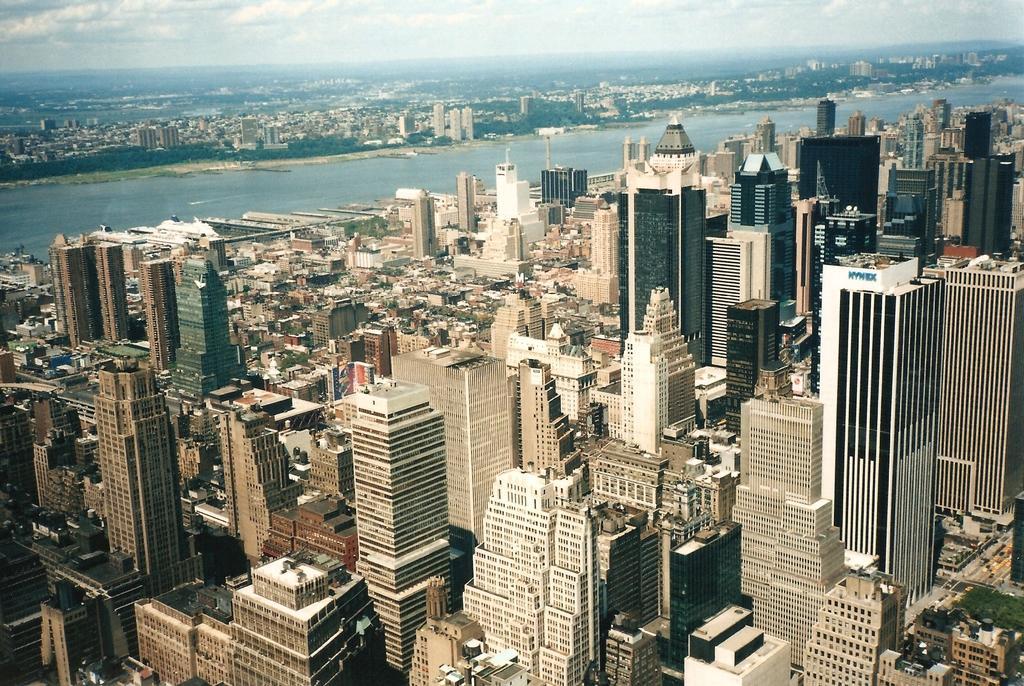Please provide a concise description of this image. This is a aerial view. In this image we can see buildings, road, water, trees, sky and clouds. 